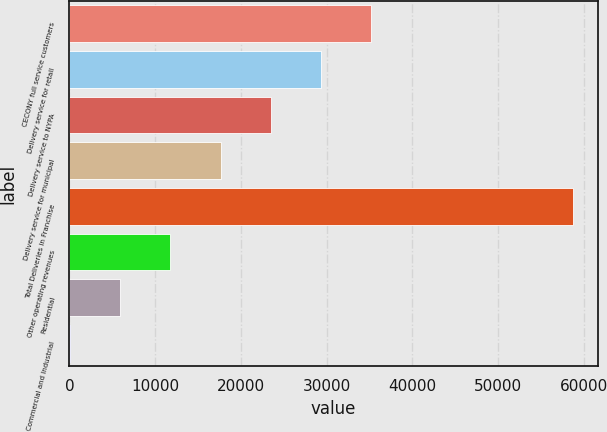Convert chart. <chart><loc_0><loc_0><loc_500><loc_500><bar_chart><fcel>CECONY full service customers<fcel>Delivery service for retail<fcel>Delivery service to NYPA<fcel>Delivery service for municipal<fcel>Total Deliveries in Franchise<fcel>Other operating revenues<fcel>Residential<fcel>Commercial and Industrial<nl><fcel>35224<fcel>29356.7<fcel>23489.4<fcel>17622.2<fcel>58693<fcel>11754.9<fcel>5887.66<fcel>20.4<nl></chart> 